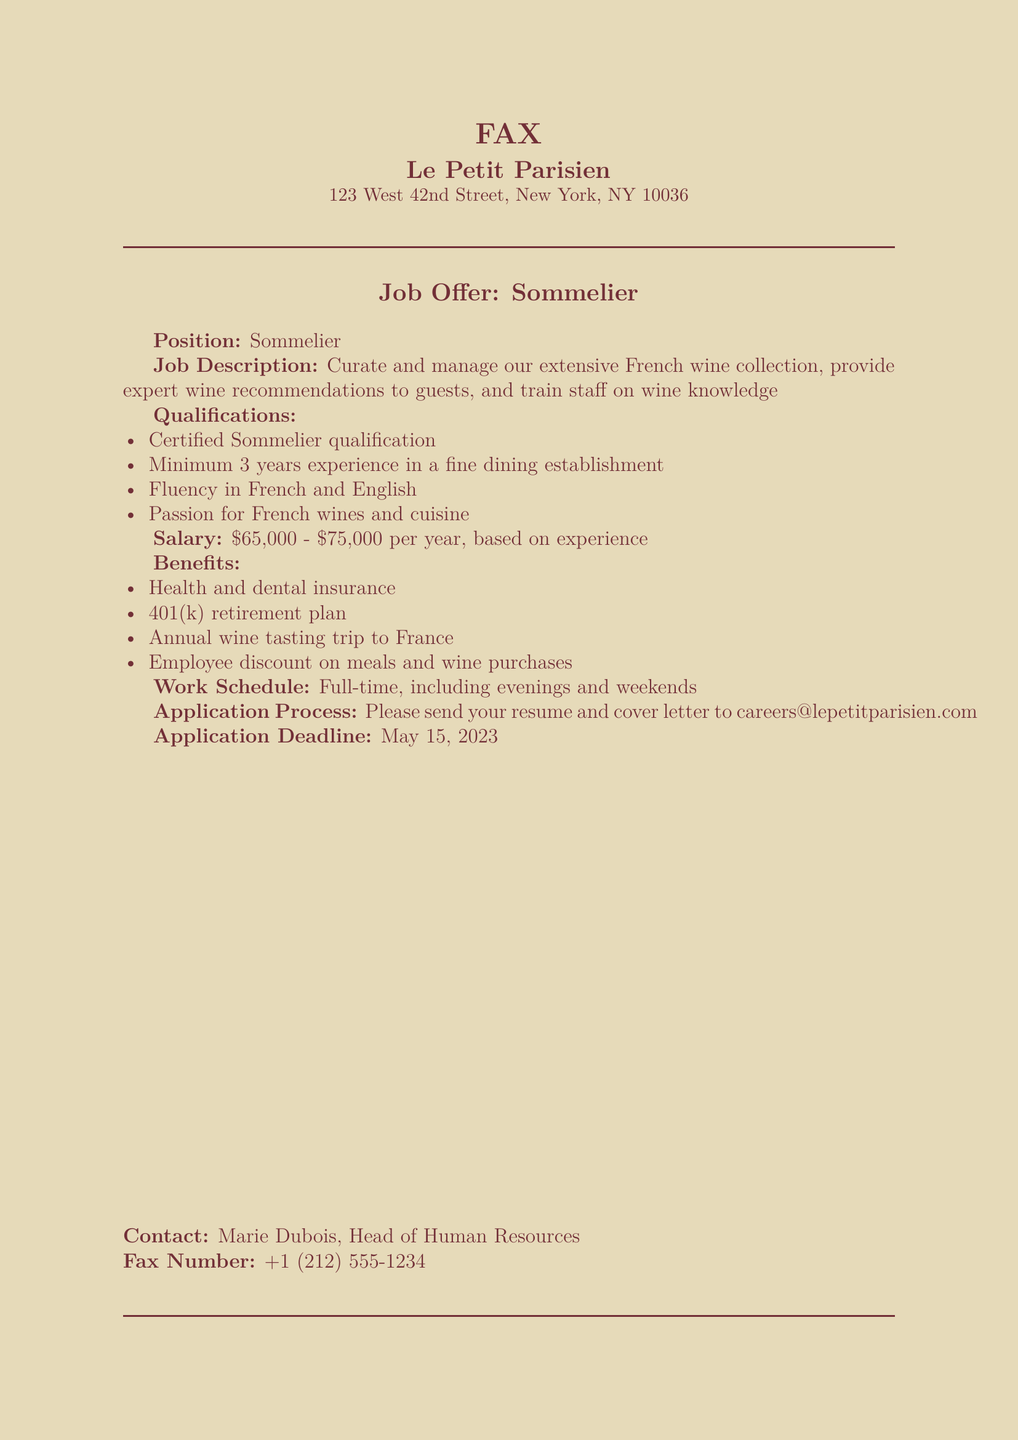what is the job title? The job title is specified in the document as the role being offered, which is Sommelier.
Answer: Sommelier what is the salary range? The document specifies the salary range for the position, which is between $65,000 and $75,000 per year.
Answer: $65,000 - $75,000 what qualifications are required? The qualifications list the essential credentials and experiences needed for the position, including Certified Sommelier qualification and minimum experience.
Answer: Certified Sommelier qualification, Minimum 3 years experience what are the benefits provided? The document outlines the benefits offered, which include several perks specific to the job, such as health insurance and an annual trip.
Answer: Health and dental insurance, 401(k) retirement plan, Annual wine tasting trip to France, Employee discount on meals and wine purchases who is the contact person for the application? The document provides the name of the person to contact regarding the job application, which is given specifically in the contact section.
Answer: Marie Dubois what languages must the candidate speak? The qualifications explicitly mention the language requirements for the position, which include fluency in two specific languages.
Answer: French and English when is the application deadline? The document states the last date to submit the application, which is a specific date provided in the application section.
Answer: May 15, 2023 what is the work schedule like? The document describes the nature of the work schedule, indicating the type of hours expected for the position.
Answer: Full-time, including evenings and weekends 